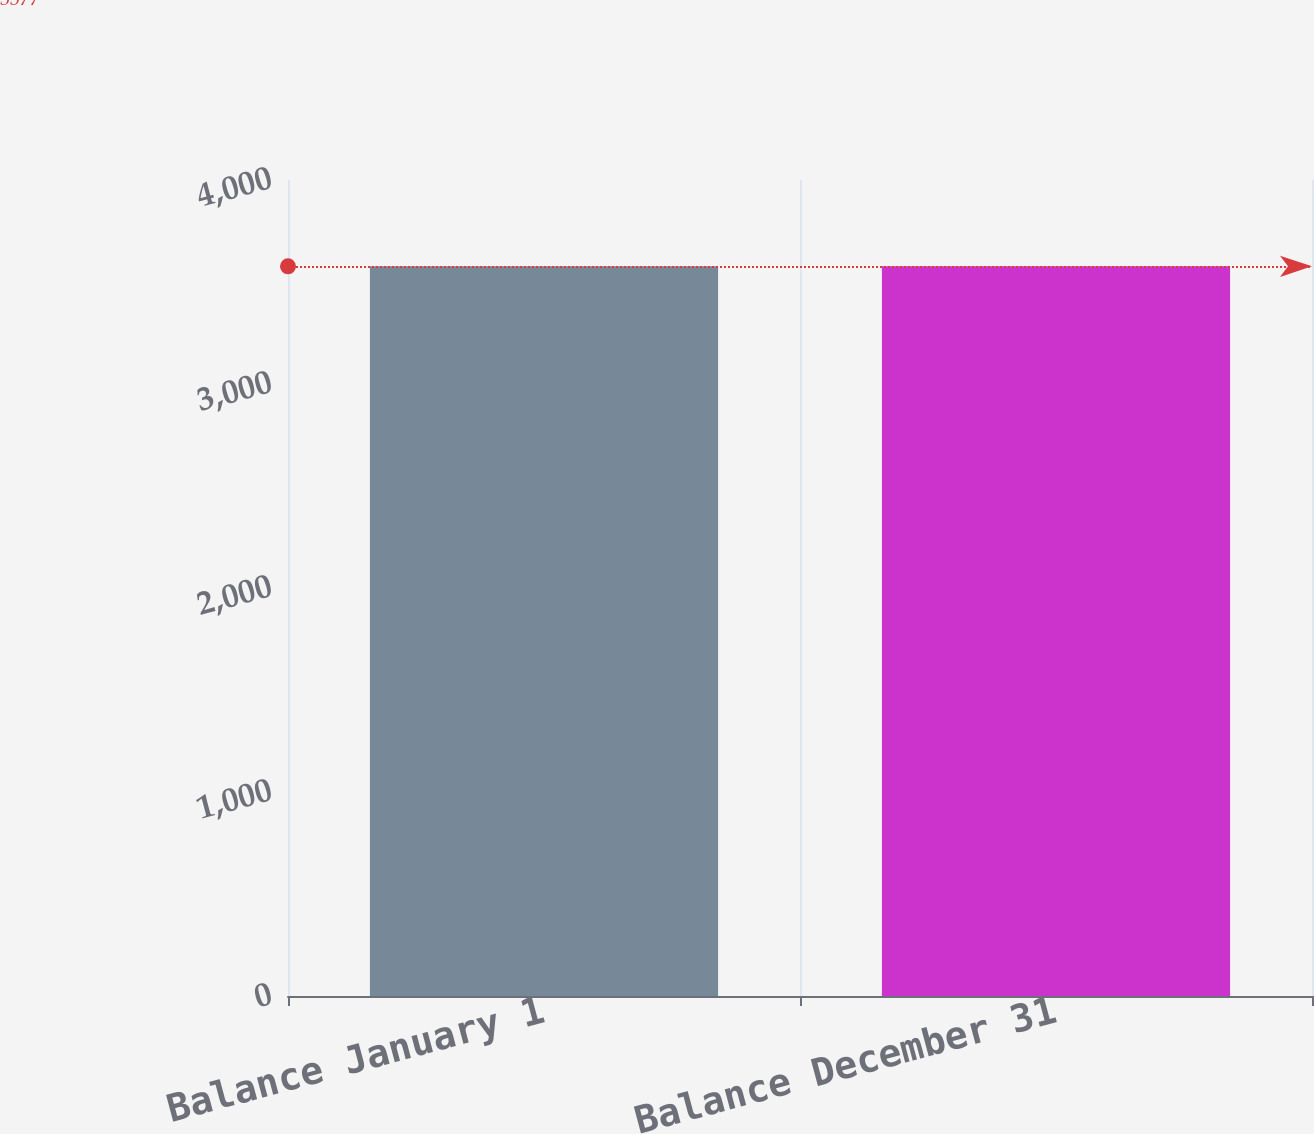<chart> <loc_0><loc_0><loc_500><loc_500><bar_chart><fcel>Balance January 1<fcel>Balance December 31<nl><fcel>3577<fcel>3577.1<nl></chart> 